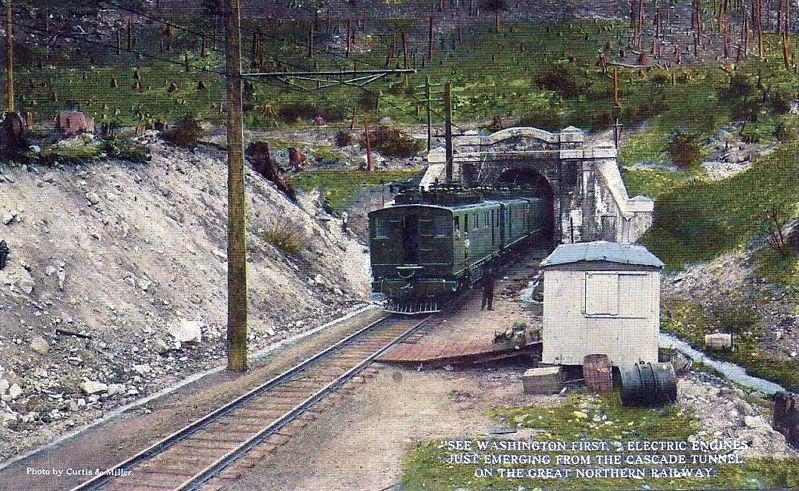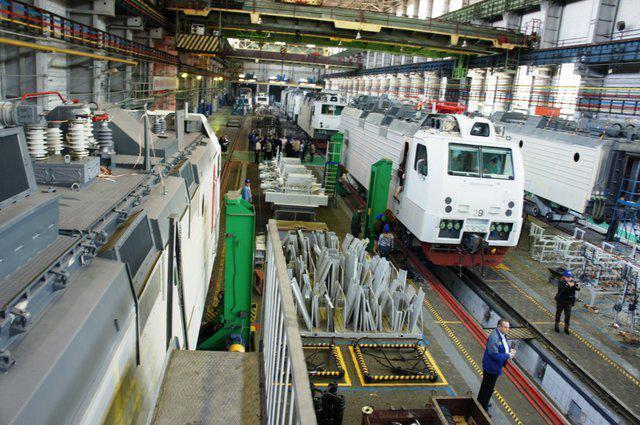The first image is the image on the left, the second image is the image on the right. For the images displayed, is the sentence "The front car of the train in the right image has a red tint to it." factually correct? Answer yes or no. No. 